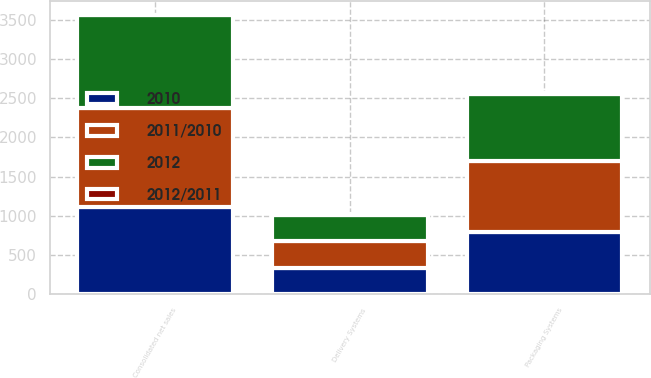Convert chart. <chart><loc_0><loc_0><loc_500><loc_500><stacked_bar_chart><ecel><fcel>Packaging Systems<fcel>Delivery Systems<fcel>Consolidated net sales<nl><fcel>2011/2010<fcel>915.1<fcel>352.1<fcel>1266.4<nl><fcel>2012<fcel>857.4<fcel>336.7<fcel>1192.3<nl><fcel>2010<fcel>785<fcel>324.1<fcel>1104.7<nl><fcel>2012/2011<fcel>6.7<fcel>4.6<fcel>6.2<nl></chart> 